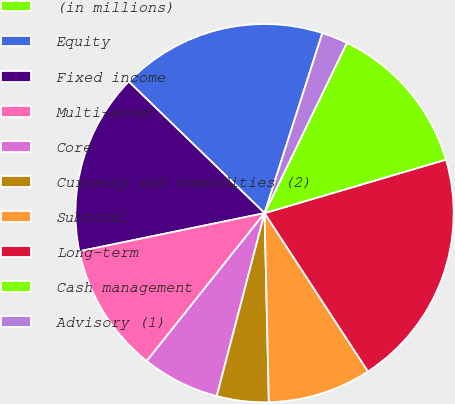<chart> <loc_0><loc_0><loc_500><loc_500><pie_chart><fcel>(in millions)<fcel>Equity<fcel>Fixed income<fcel>Multi-asset<fcel>Core<fcel>Currency and commodities (2)<fcel>Subtotal<fcel>Long-term<fcel>Cash management<fcel>Advisory (1)<nl><fcel>0.01%<fcel>17.69%<fcel>15.48%<fcel>11.06%<fcel>6.64%<fcel>4.43%<fcel>8.85%<fcel>20.36%<fcel>13.27%<fcel>2.22%<nl></chart> 